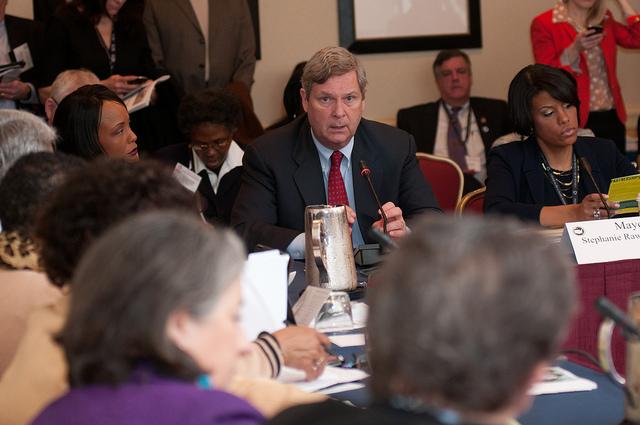Is there a woman wearing a red jacket?
Concise answer only. Yes. Is the man in the red tie an important person?
Answer briefly. Yes. What is the man speaking into?
Be succinct. Microphone. 